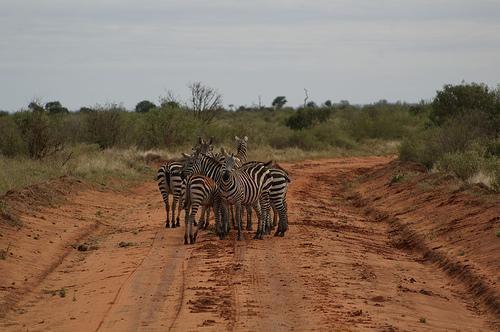How many zebras can you count?
Give a very brief answer. 5. How many type of animals are blocking the dirt road?
Give a very brief answer. 1. How many zebras are there?
Give a very brief answer. 2. 